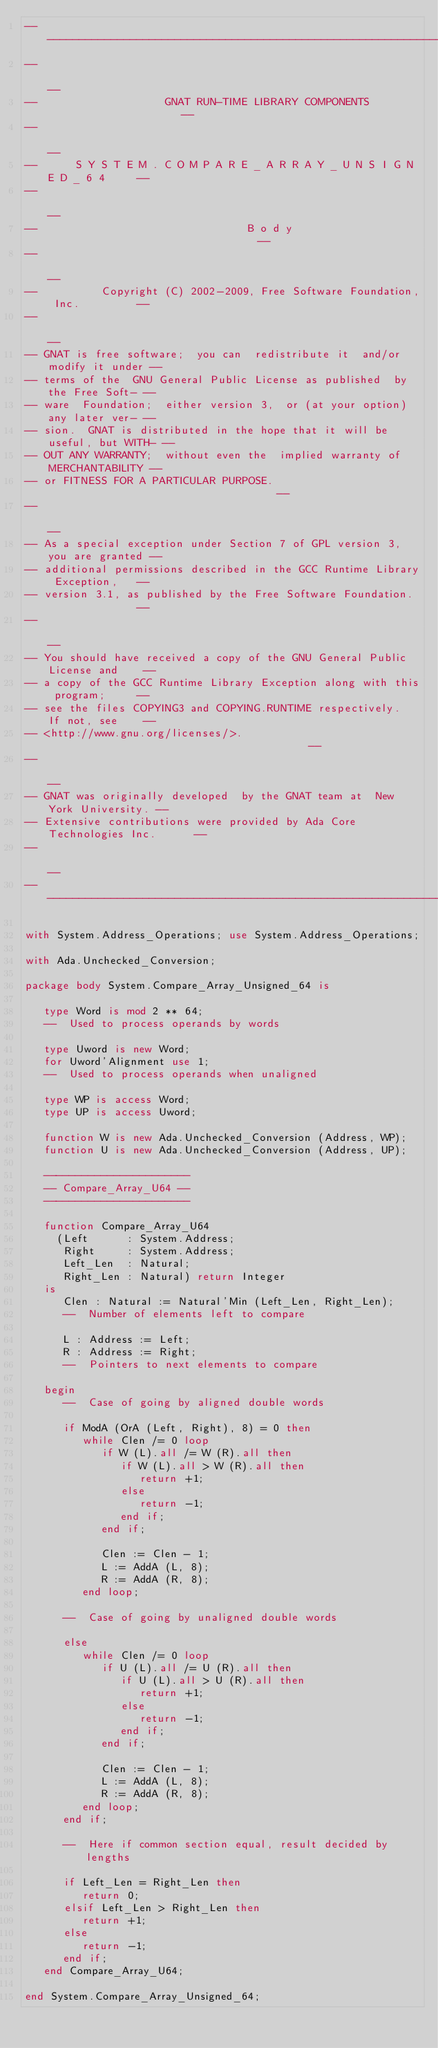Convert code to text. <code><loc_0><loc_0><loc_500><loc_500><_Ada_>------------------------------------------------------------------------------
--                                                                          --
--                    GNAT RUN-TIME LIBRARY COMPONENTS                      --
--                                                                          --
--      S Y S T E M . C O M P A R E _ A R R A Y _ U N S I G N E D _ 6 4     --
--                                                                          --
--                                 B o d y                                  --
--                                                                          --
--          Copyright (C) 2002-2009, Free Software Foundation, Inc.         --
--                                                                          --
-- GNAT is free software;  you can  redistribute it  and/or modify it under --
-- terms of the  GNU General Public License as published  by the Free Soft- --
-- ware  Foundation;  either version 3,  or (at your option) any later ver- --
-- sion.  GNAT is distributed in the hope that it will be useful, but WITH- --
-- OUT ANY WARRANTY;  without even the  implied warranty of MERCHANTABILITY --
-- or FITNESS FOR A PARTICULAR PURPOSE.                                     --
--                                                                          --
-- As a special exception under Section 7 of GPL version 3, you are granted --
-- additional permissions described in the GCC Runtime Library Exception,   --
-- version 3.1, as published by the Free Software Foundation.               --
--                                                                          --
-- You should have received a copy of the GNU General Public License and    --
-- a copy of the GCC Runtime Library Exception along with this program;     --
-- see the files COPYING3 and COPYING.RUNTIME respectively.  If not, see    --
-- <http://www.gnu.org/licenses/>.                                          --
--                                                                          --
-- GNAT was originally developed  by the GNAT team at  New York University. --
-- Extensive contributions were provided by Ada Core Technologies Inc.      --
--                                                                          --
------------------------------------------------------------------------------

with System.Address_Operations; use System.Address_Operations;

with Ada.Unchecked_Conversion;

package body System.Compare_Array_Unsigned_64 is

   type Word is mod 2 ** 64;
   --  Used to process operands by words

   type Uword is new Word;
   for Uword'Alignment use 1;
   --  Used to process operands when unaligned

   type WP is access Word;
   type UP is access Uword;

   function W is new Ada.Unchecked_Conversion (Address, WP);
   function U is new Ada.Unchecked_Conversion (Address, UP);

   -----------------------
   -- Compare_Array_U64 --
   -----------------------

   function Compare_Array_U64
     (Left      : System.Address;
      Right     : System.Address;
      Left_Len  : Natural;
      Right_Len : Natural) return Integer
   is
      Clen : Natural := Natural'Min (Left_Len, Right_Len);
      --  Number of elements left to compare

      L : Address := Left;
      R : Address := Right;
      --  Pointers to next elements to compare

   begin
      --  Case of going by aligned double words

      if ModA (OrA (Left, Right), 8) = 0 then
         while Clen /= 0 loop
            if W (L).all /= W (R).all then
               if W (L).all > W (R).all then
                  return +1;
               else
                  return -1;
               end if;
            end if;

            Clen := Clen - 1;
            L := AddA (L, 8);
            R := AddA (R, 8);
         end loop;

      --  Case of going by unaligned double words

      else
         while Clen /= 0 loop
            if U (L).all /= U (R).all then
               if U (L).all > U (R).all then
                  return +1;
               else
                  return -1;
               end if;
            end if;

            Clen := Clen - 1;
            L := AddA (L, 8);
            R := AddA (R, 8);
         end loop;
      end if;

      --  Here if common section equal, result decided by lengths

      if Left_Len = Right_Len then
         return 0;
      elsif Left_Len > Right_Len then
         return +1;
      else
         return -1;
      end if;
   end Compare_Array_U64;

end System.Compare_Array_Unsigned_64;
</code> 